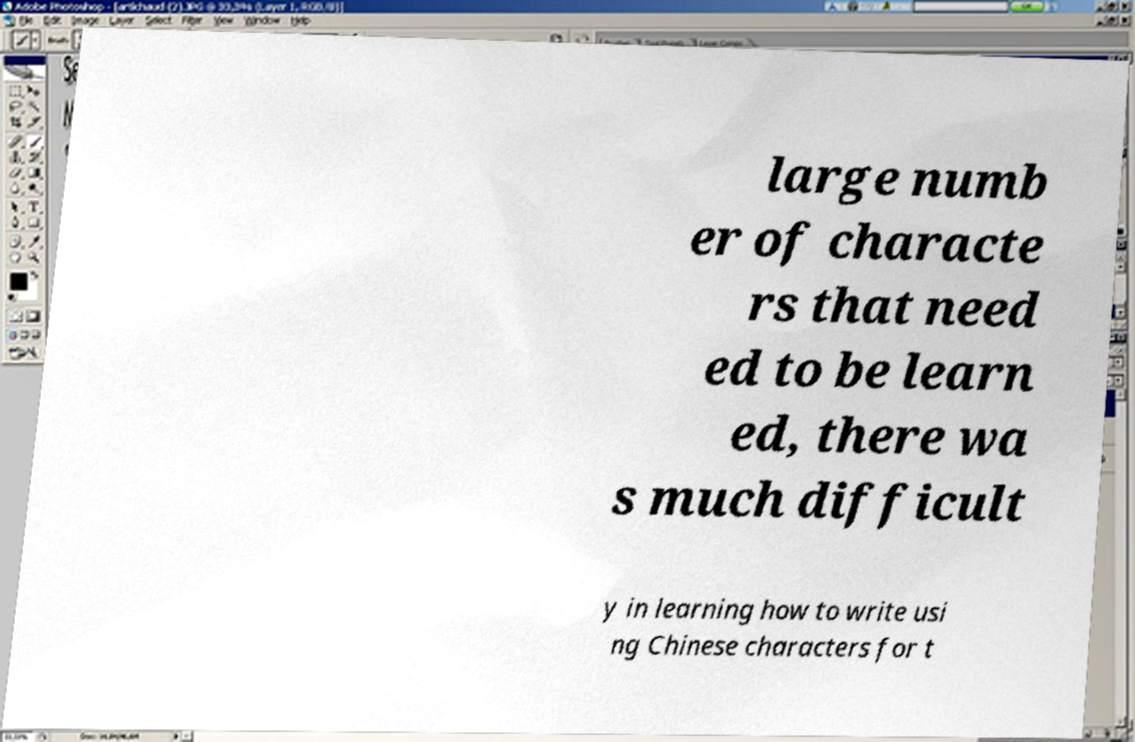For documentation purposes, I need the text within this image transcribed. Could you provide that? large numb er of characte rs that need ed to be learn ed, there wa s much difficult y in learning how to write usi ng Chinese characters for t 